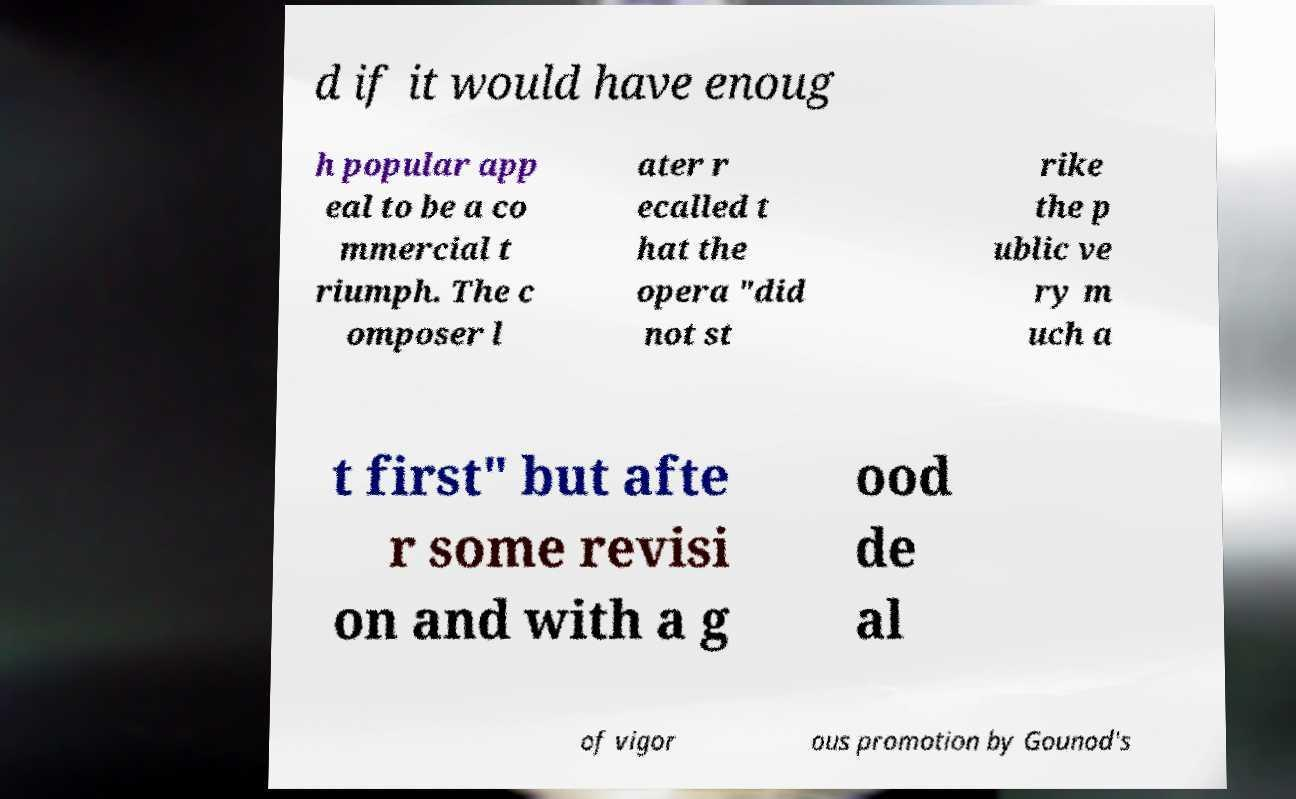I need the written content from this picture converted into text. Can you do that? d if it would have enoug h popular app eal to be a co mmercial t riumph. The c omposer l ater r ecalled t hat the opera "did not st rike the p ublic ve ry m uch a t first" but afte r some revisi on and with a g ood de al of vigor ous promotion by Gounod's 